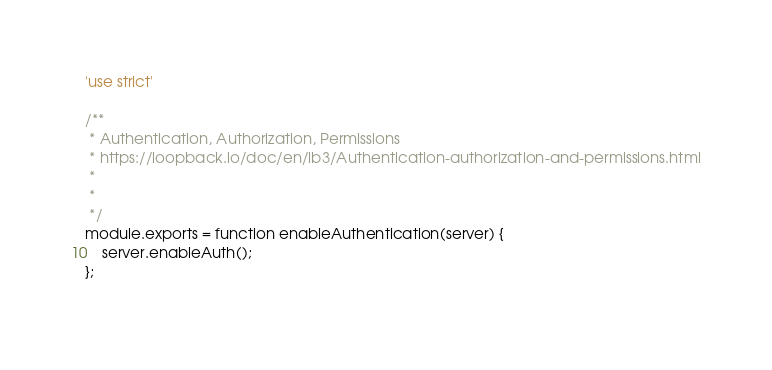<code> <loc_0><loc_0><loc_500><loc_500><_JavaScript_>'use strict'

/**
 * Authentication, Authorization, Permissions
 * https://loopback.io/doc/en/lb3/Authentication-authorization-and-permissions.html
 * 
 * 
 */
module.exports = function enableAuthentication(server) {
    server.enableAuth();
};
  </code> 